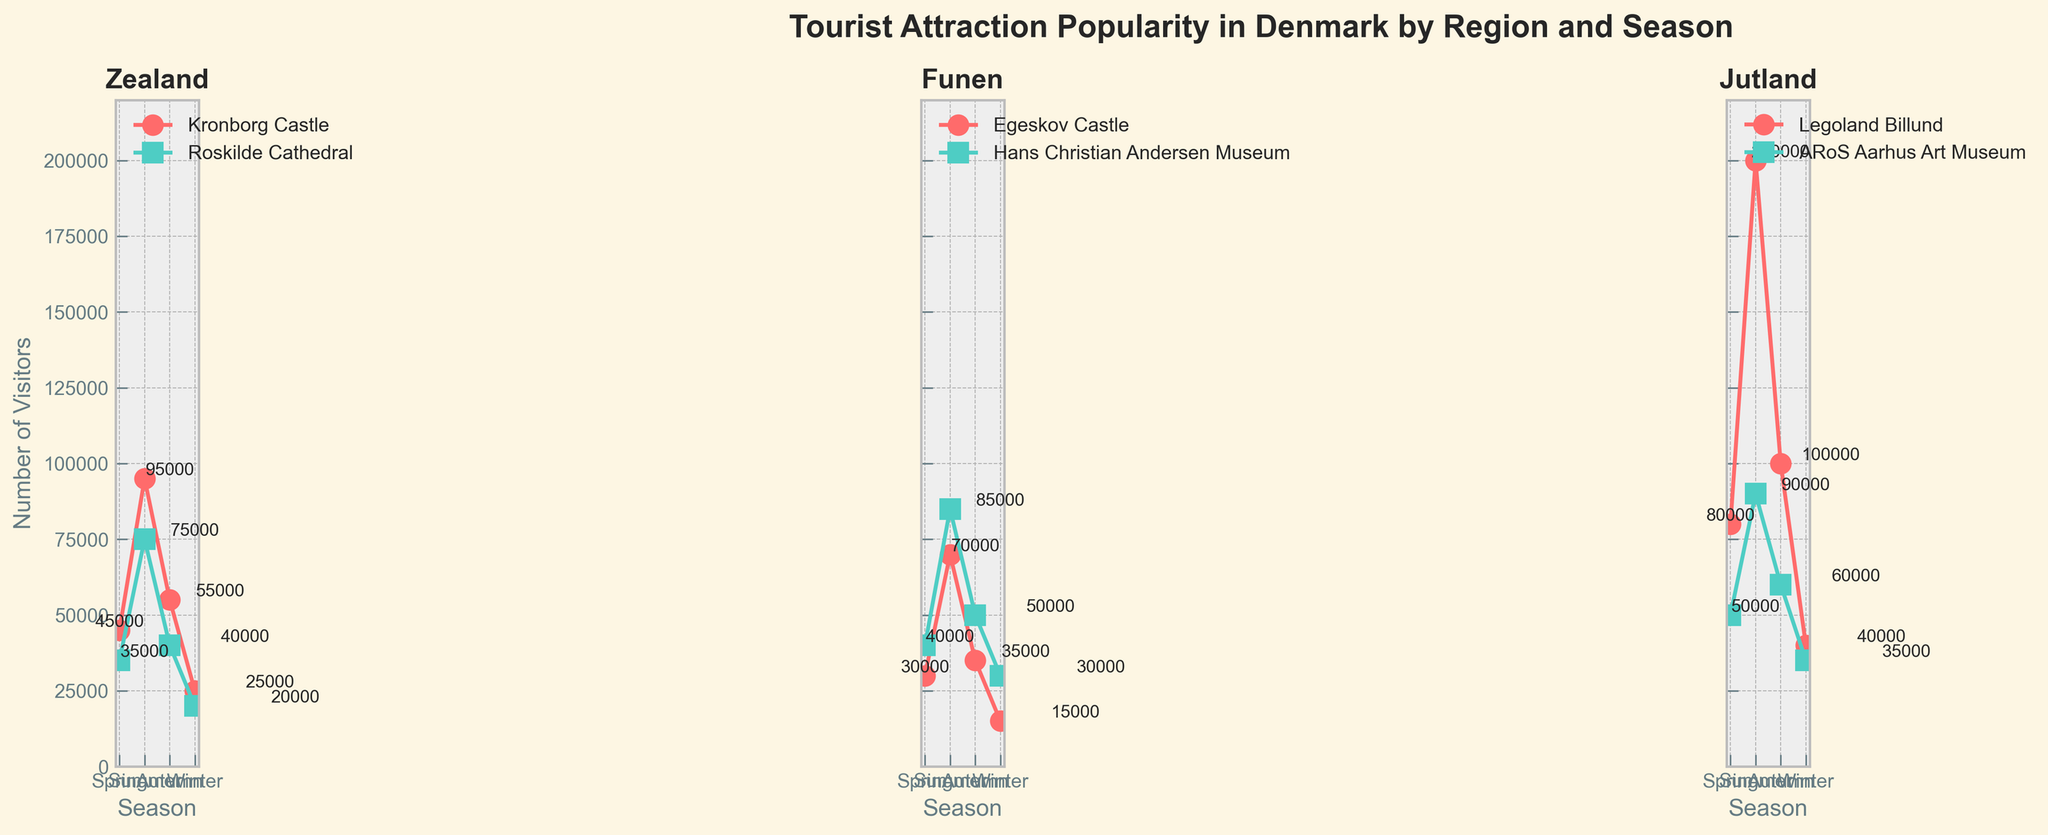What is the total number of visitors to Kronborg Castle in all regions during the summer season? The figure shows that Kronborg Castle only appears in the Zealand region. In the summer, Kronborg Castle in Zealand had 95,000 visitors.
Answer: 95,000 Which region had the highest number of visitors to the attractions combined during the spring season? The figure shows the number of visitors to each attraction by region. For the spring season, adding up the number of visitors for each region: Zealand (45,000 + 35,000 = 80,000), Funen (30,000 + 40,000 = 70,000), Jutland (80,000 + 50,000 = 130,000). Jutland has the highest combined number of visitors.
Answer: Jutland How many more visitors did Legoland Billund have compared to ARoS Aarhus Art Museum in Jutland during the autumn season? In the autumn season, Legoland Billund had 100,000 visitors, while ARoS Aarhus Art Museum had 60,000 visitors. The difference is 100,000 - 60,000.
Answer: 40,000 Which attraction in Funen had the higher number of visitors during the winter season? By looking at the figure for winter season in Funen, Egeskov Castle had 15,000 visitors, while Hans Christian Andersen Museum had 30,000 visitors.
Answer: Hans Christian Andersen Museum What is the average number of visitors to Roskilde Cathedral across all seasons? The figure shows that Roskilde Cathedral had 35,000 visitors in spring, 75,000 in summer, 40,000 in autumn, and 20,000 in winter. The average is calculated as (35,000 + 75,000 + 40,000 + 20,000) / 4.
Answer: 42,500 Which season had the fewest visitors to attractions in Jutland? For each season in Jutland, sum the visitors: Spring (80,000 + 50,000 = 130,000), Summer (200,000 + 90,000 = 290,000), Autumn (100,000 + 60,000 = 160,000), Winter (40,000 + 35,000 = 75,000). Winter had the fewest visitors.
Answer: Winter How did the number of visitors to the Hans Christian Andersen Museum in Funen change from spring to summer? In spring, Hans Christian Andersen Museum had 40,000 visitors, and in summer, it had 85,000 visitors. The change is 85,000 - 40,000.
Answer: Increased by 45,000 In which season did Zealand have the highest total visitors, and what was the total? By summing the visitors by season in Zealand: Spring (45,000 + 35,000 = 80,000), Summer (95,000 + 75,000 = 170,000), Autumn (55,000 + 40,000 = 95,000), Winter (25,000 + 20,000 = 45,000). The highest total was in summer with 170,000 visitors.
Answer: Summer, 170,000 Comparing all seasons, which region and season had the lowest visitor count for a single attraction? From the figure, the lowest visitor count is in the Winter season for Egeskov Castle in Funen with 15,000 visitors.
Answer: Funen, Winter 